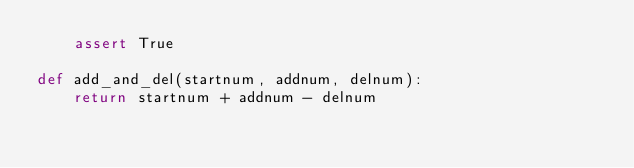<code> <loc_0><loc_0><loc_500><loc_500><_Python_>	assert True

def add_and_del(startnum, addnum, delnum):
	return startnum + addnum - delnum
</code> 